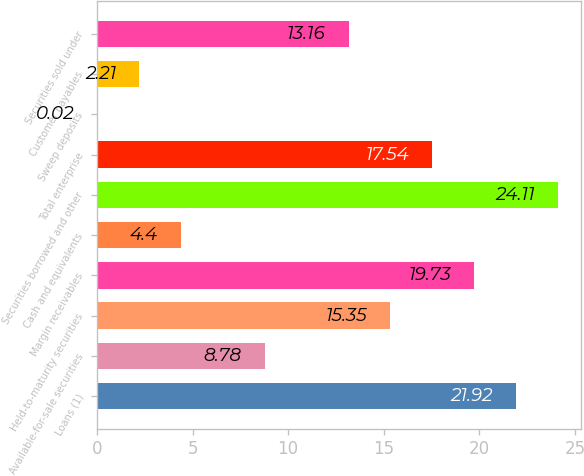<chart> <loc_0><loc_0><loc_500><loc_500><bar_chart><fcel>Loans (1)<fcel>Available-for-sale securities<fcel>Held-to-maturity securities<fcel>Margin receivables<fcel>Cash and equivalents<fcel>Securities borrowed and other<fcel>Total enterprise<fcel>Sweep deposits<fcel>Customer payables<fcel>Securities sold under<nl><fcel>21.92<fcel>8.78<fcel>15.35<fcel>19.73<fcel>4.4<fcel>24.11<fcel>17.54<fcel>0.02<fcel>2.21<fcel>13.16<nl></chart> 